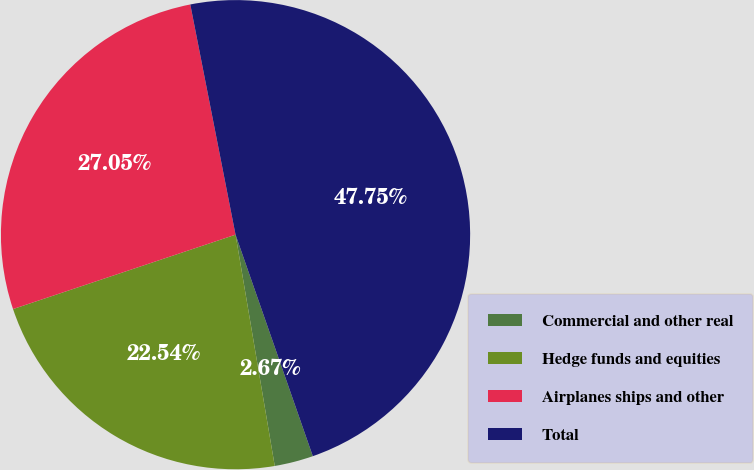Convert chart. <chart><loc_0><loc_0><loc_500><loc_500><pie_chart><fcel>Commercial and other real<fcel>Hedge funds and equities<fcel>Airplanes ships and other<fcel>Total<nl><fcel>2.67%<fcel>22.54%<fcel>27.05%<fcel>47.75%<nl></chart> 